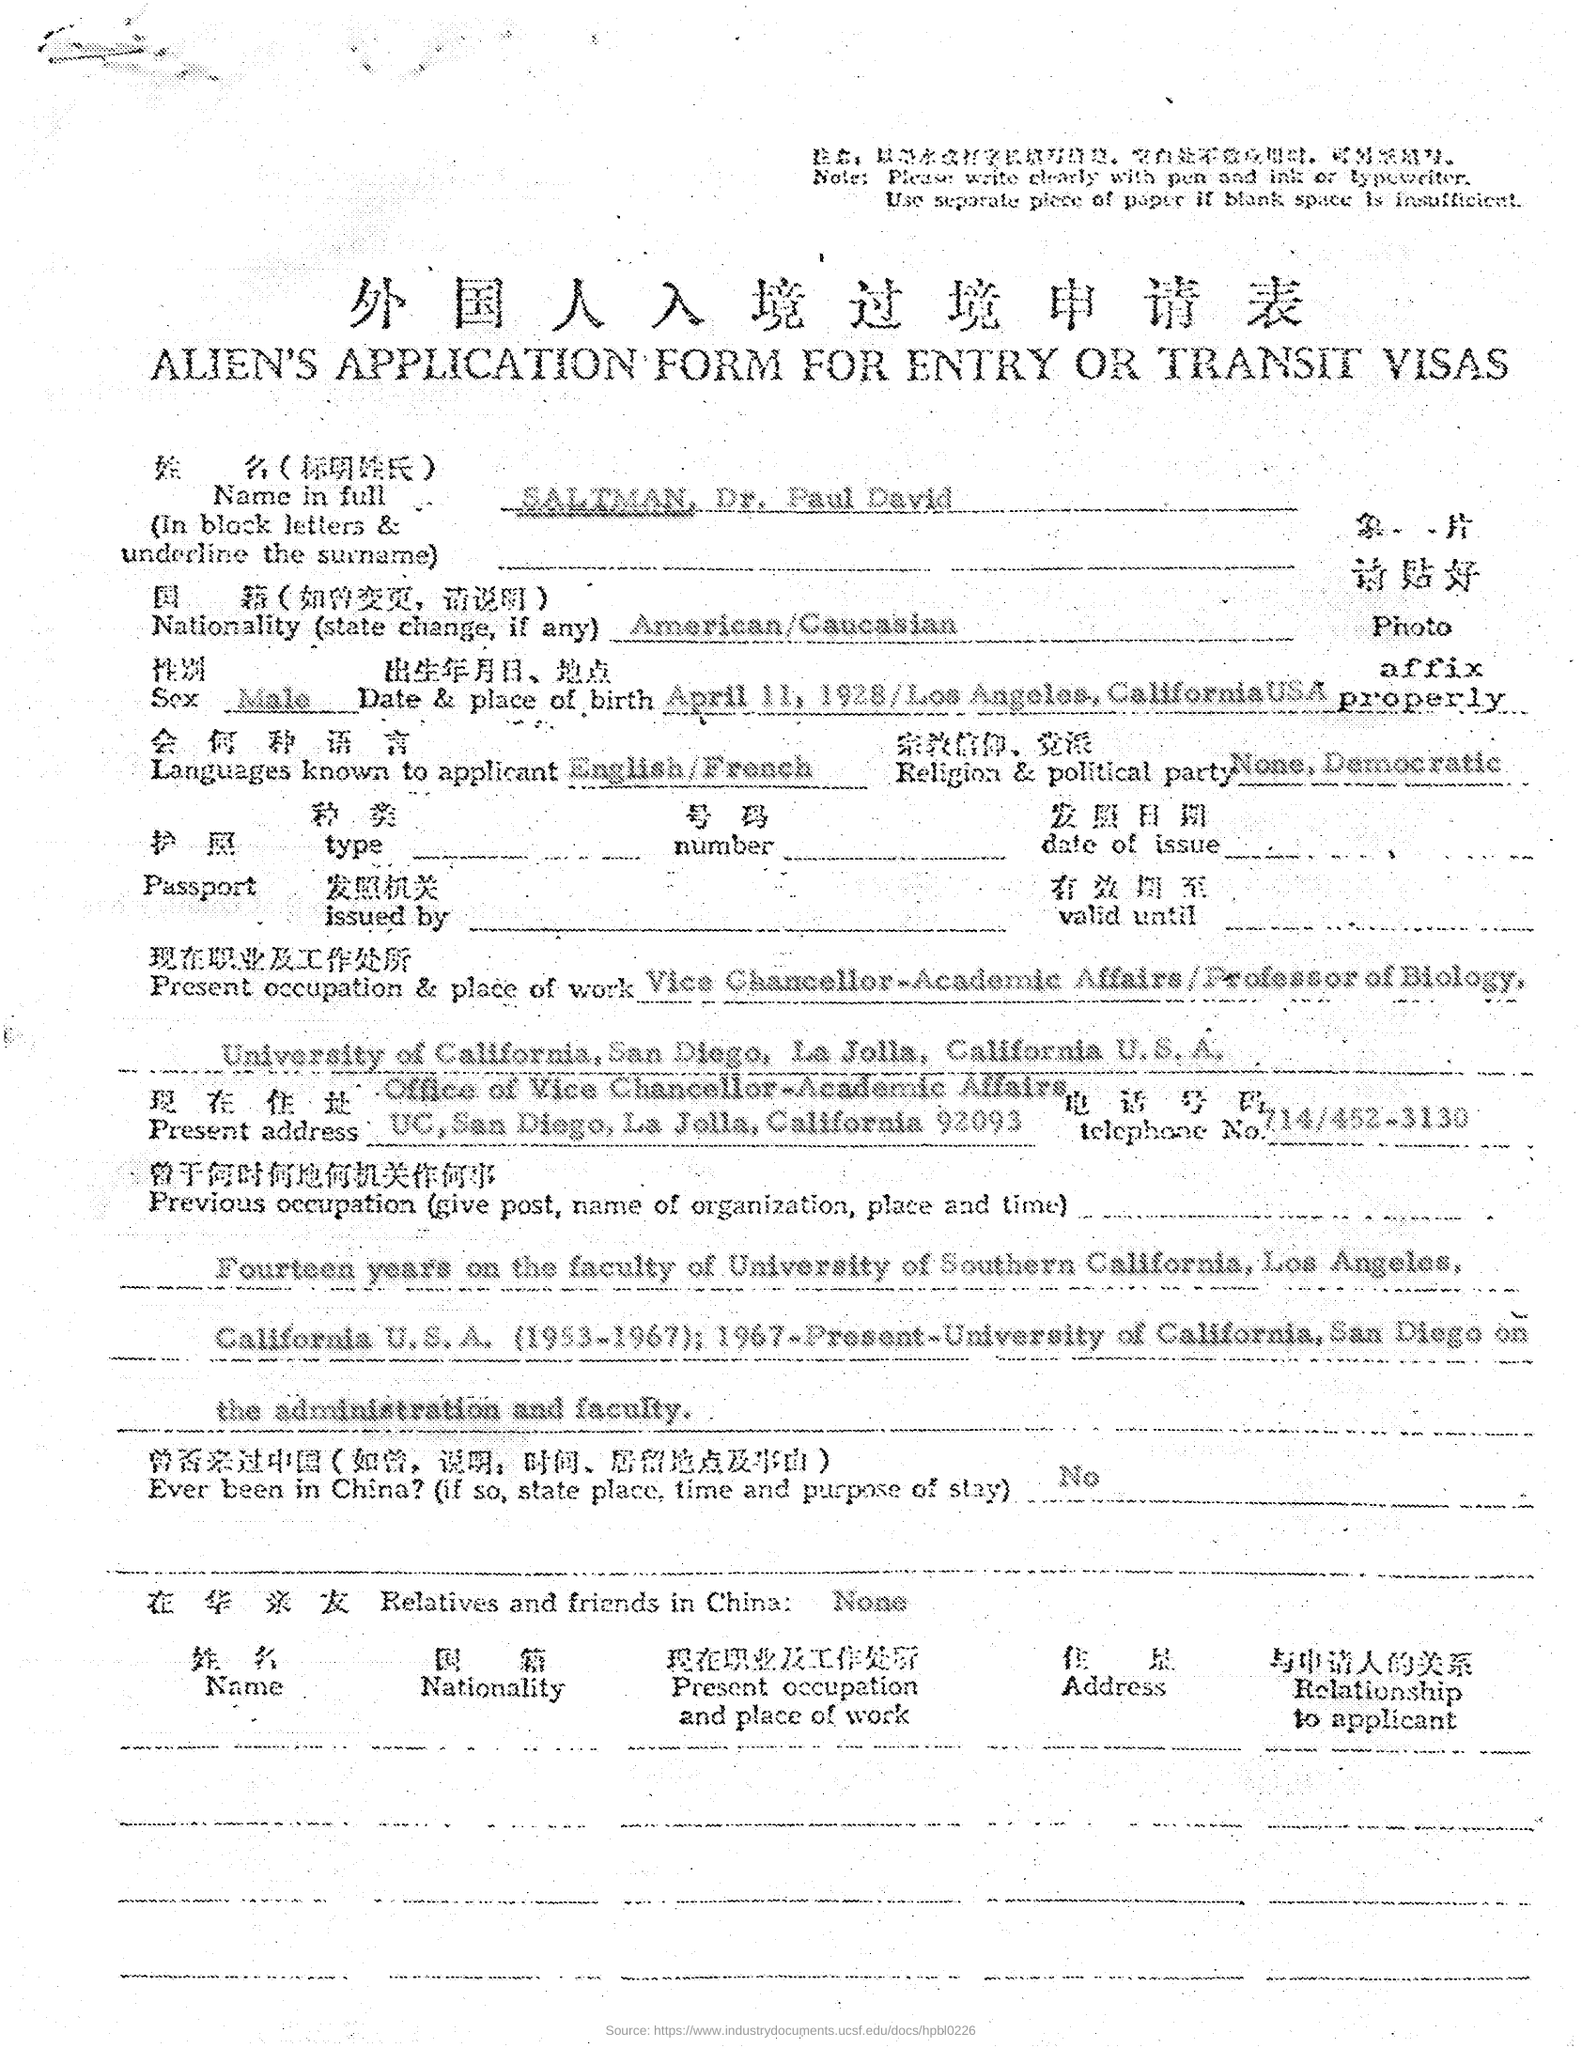Draw attention to some important aspects in this diagram. The telephone number of Dr. Paul David Saltman mentioned in the application is 714/452-3130. There were no relatives or friends of Dr. Paul David Saltman in China. The name that appears on the application form is "SALTMAN, Dr. Paul David. Dr. Paul David SALTMAN was born on April 11, 1928. 